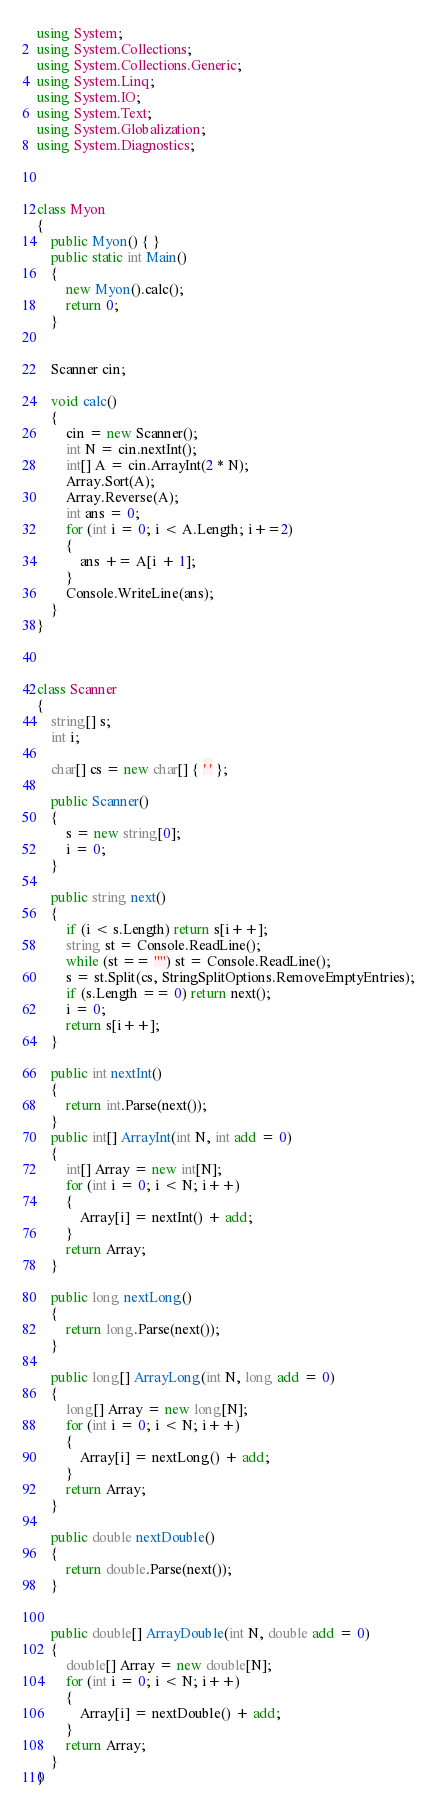Convert code to text. <code><loc_0><loc_0><loc_500><loc_500><_C#_>using System;
using System.Collections;
using System.Collections.Generic;
using System.Linq;
using System.IO;
using System.Text;
using System.Globalization;
using System.Diagnostics;



class Myon
{
    public Myon() { }
    public static int Main()
    {
        new Myon().calc();
        return 0;
    }
    

    Scanner cin;
    
    void calc()
    {
        cin = new Scanner();
        int N = cin.nextInt();
        int[] A = cin.ArrayInt(2 * N);
        Array.Sort(A);
        Array.Reverse(A);
        int ans = 0;
        for (int i = 0; i < A.Length; i+=2)
        {
            ans += A[i + 1];
        }
        Console.WriteLine(ans);
    }
}



class Scanner
{
    string[] s;
    int i;

    char[] cs = new char[] { ' ' };

    public Scanner()
    {
        s = new string[0];
        i = 0;
    }

    public string next()
    {
        if (i < s.Length) return s[i++];
        string st = Console.ReadLine();
        while (st == "") st = Console.ReadLine();
        s = st.Split(cs, StringSplitOptions.RemoveEmptyEntries);
        if (s.Length == 0) return next();
        i = 0;
        return s[i++];
    }

    public int nextInt()
    {
        return int.Parse(next());
    }
    public int[] ArrayInt(int N, int add = 0)
    {
        int[] Array = new int[N];
        for (int i = 0; i < N; i++)
        {
            Array[i] = nextInt() + add;
        }
        return Array;
    }

    public long nextLong()
    {
        return long.Parse(next());
    }

    public long[] ArrayLong(int N, long add = 0)
    {
        long[] Array = new long[N];
        for (int i = 0; i < N; i++)
        {
            Array[i] = nextLong() + add;
        }
        return Array;
    }

    public double nextDouble()
    {
        return double.Parse(next());
    }


    public double[] ArrayDouble(int N, double add = 0)
    {
        double[] Array = new double[N];
        for (int i = 0; i < N; i++)
        {
            Array[i] = nextDouble() + add;
        }
        return Array;
    }
}</code> 